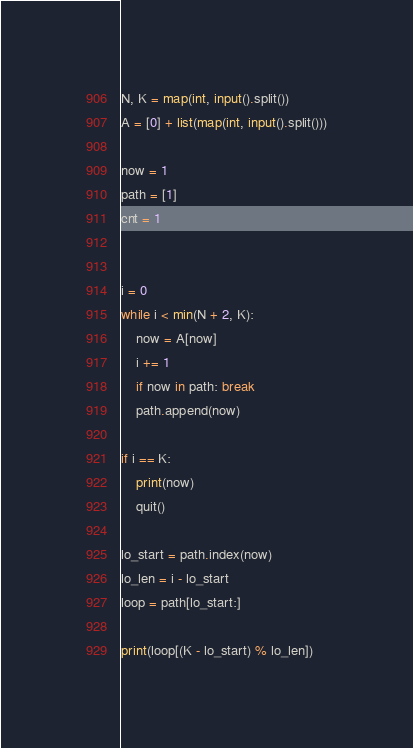<code> <loc_0><loc_0><loc_500><loc_500><_Python_>N, K = map(int, input().split())
A = [0] + list(map(int, input().split()))

now = 1
path = [1]
cnt = 1


i = 0
while i < min(N + 2, K):
    now = A[now]
    i += 1
    if now in path: break
    path.append(now)

if i == K:
    print(now)
    quit()

lo_start = path.index(now)
lo_len = i - lo_start
loop = path[lo_start:]

print(loop[(K - lo_start) % lo_len])</code> 